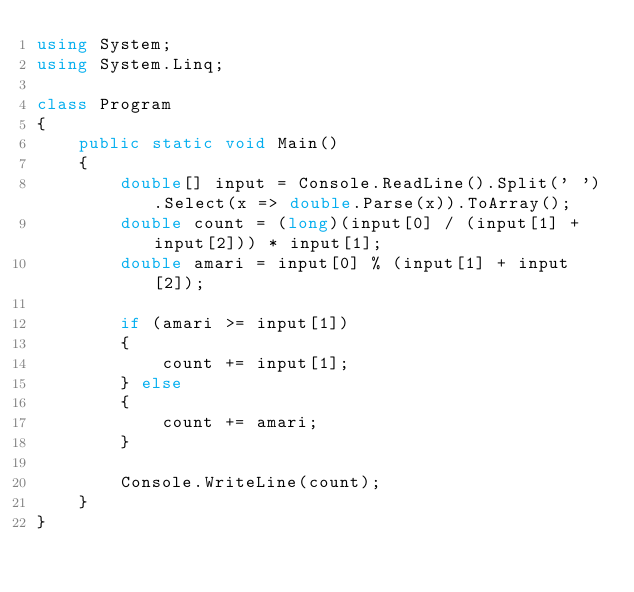<code> <loc_0><loc_0><loc_500><loc_500><_C#_>using System;
using System.Linq;

class Program
{
    public static void Main()
    {
        double[] input = Console.ReadLine().Split(' ').Select(x => double.Parse(x)).ToArray();
        double count = (long)(input[0] / (input[1] + input[2])) * input[1];
        double amari = input[0] % (input[1] + input[2]);

        if (amari >= input[1])
        {
            count += input[1];
        } else
        {
            count += amari;
        }

        Console.WriteLine(count);
    }
}</code> 